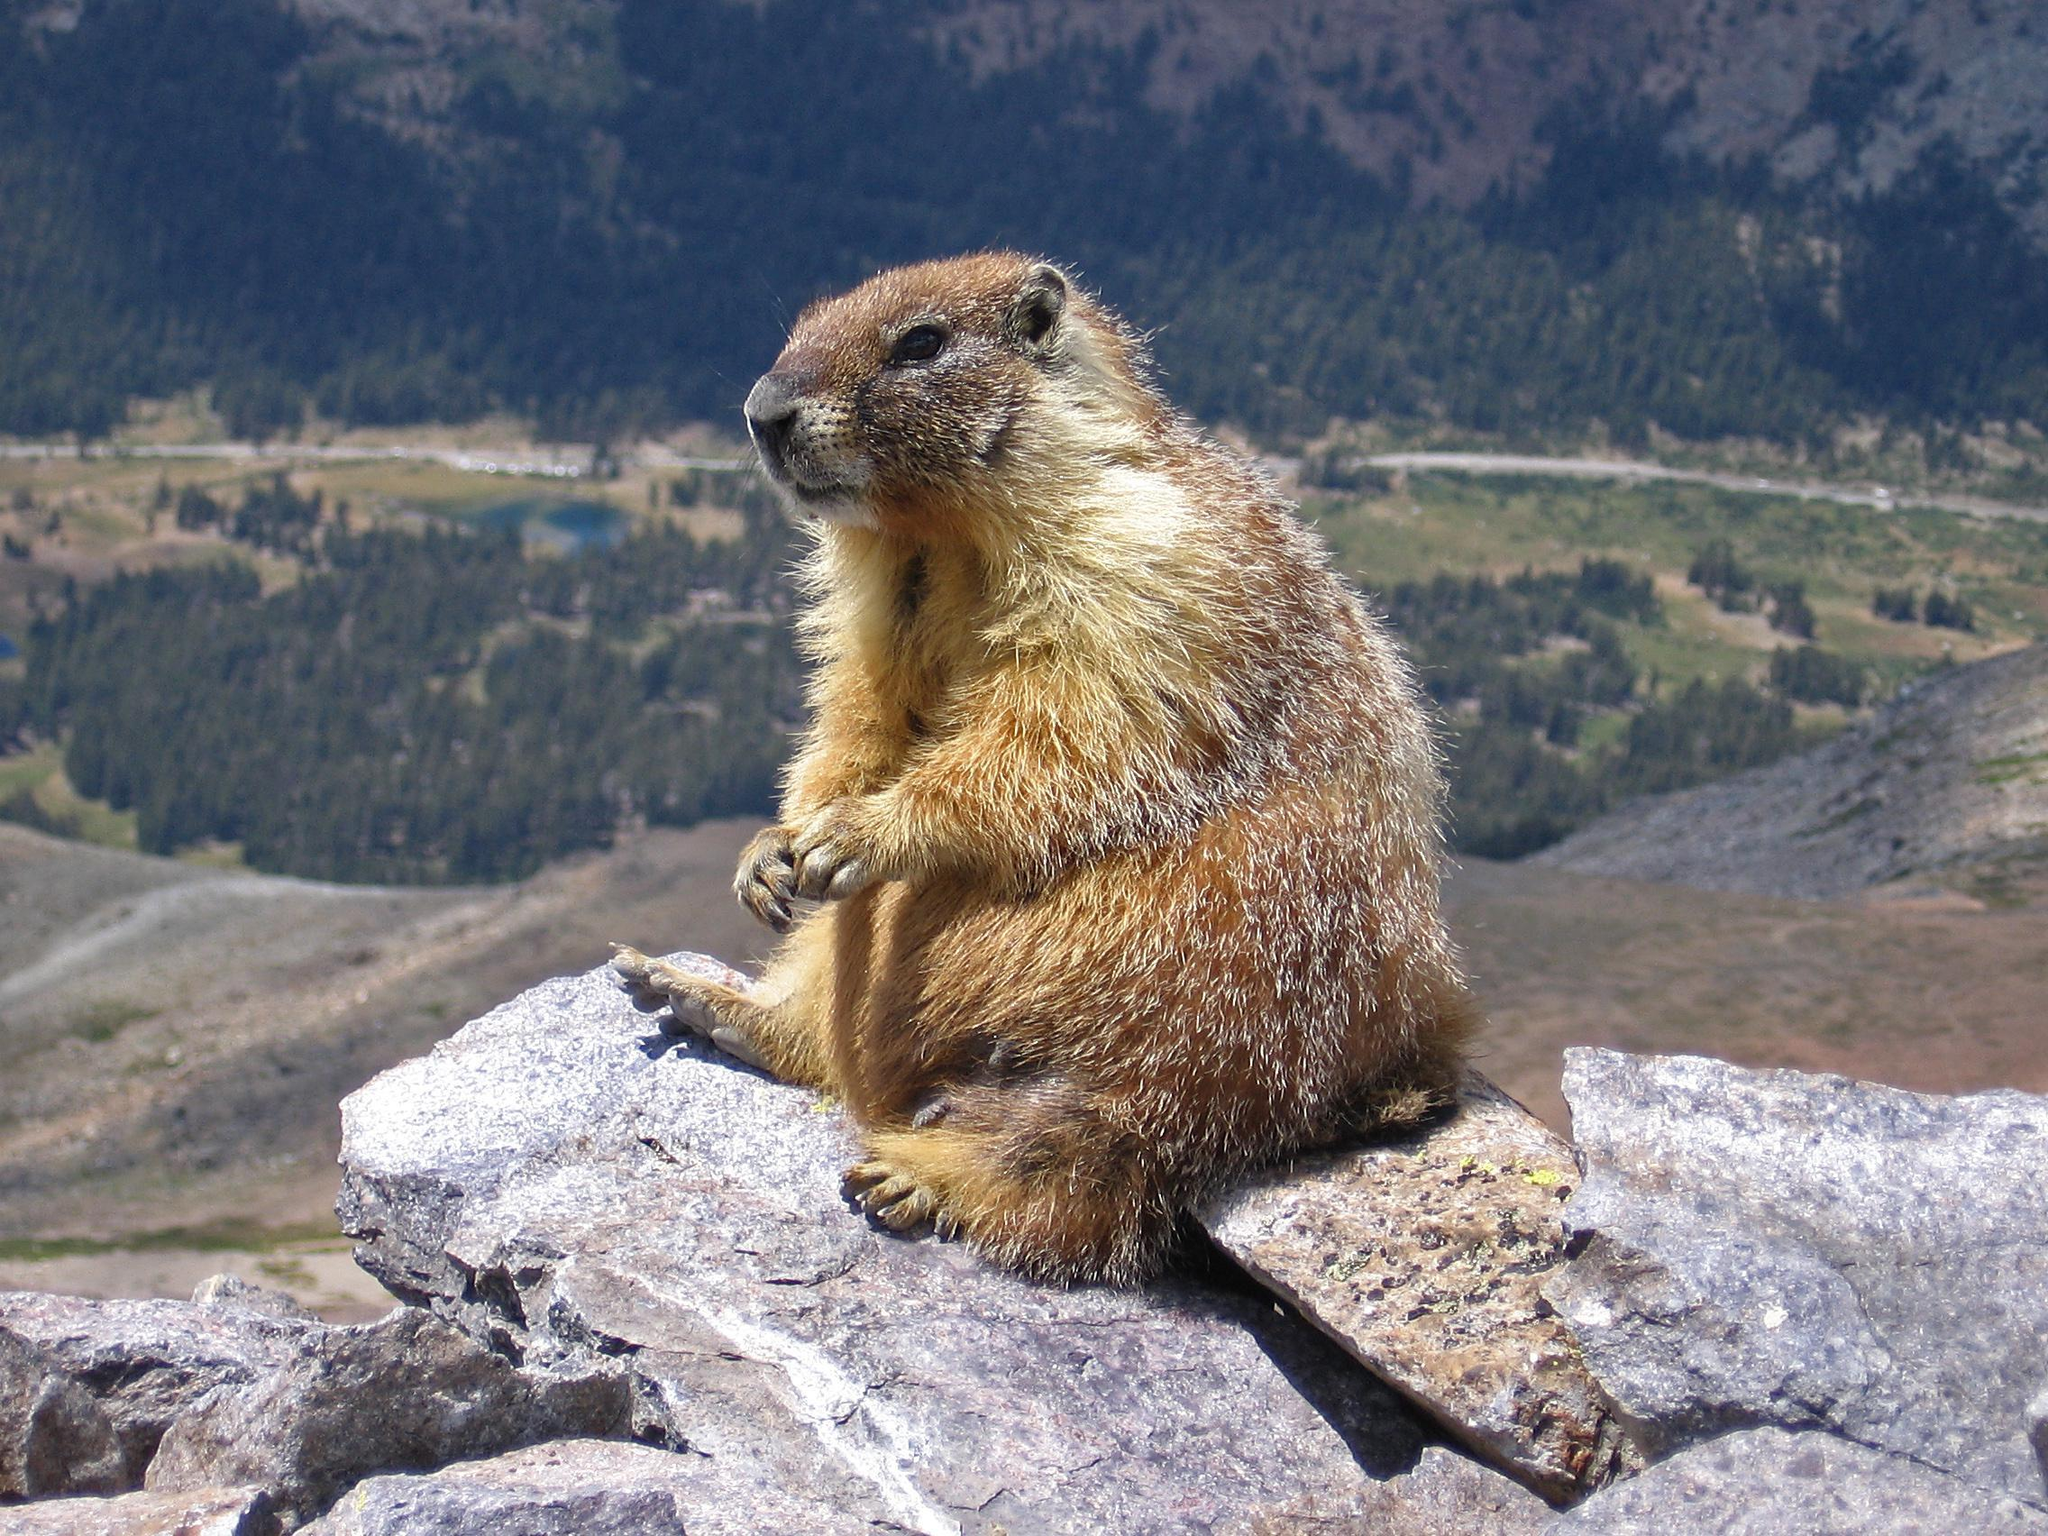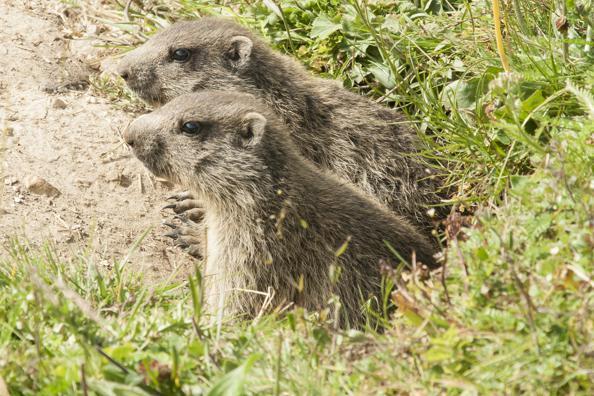The first image is the image on the left, the second image is the image on the right. Evaluate the accuracy of this statement regarding the images: "At least one image contains 3 or more animals.". Is it true? Answer yes or no. No. The first image is the image on the left, the second image is the image on the right. Assess this claim about the two images: "In each image, there are at least two animals.". Correct or not? Answer yes or no. No. 